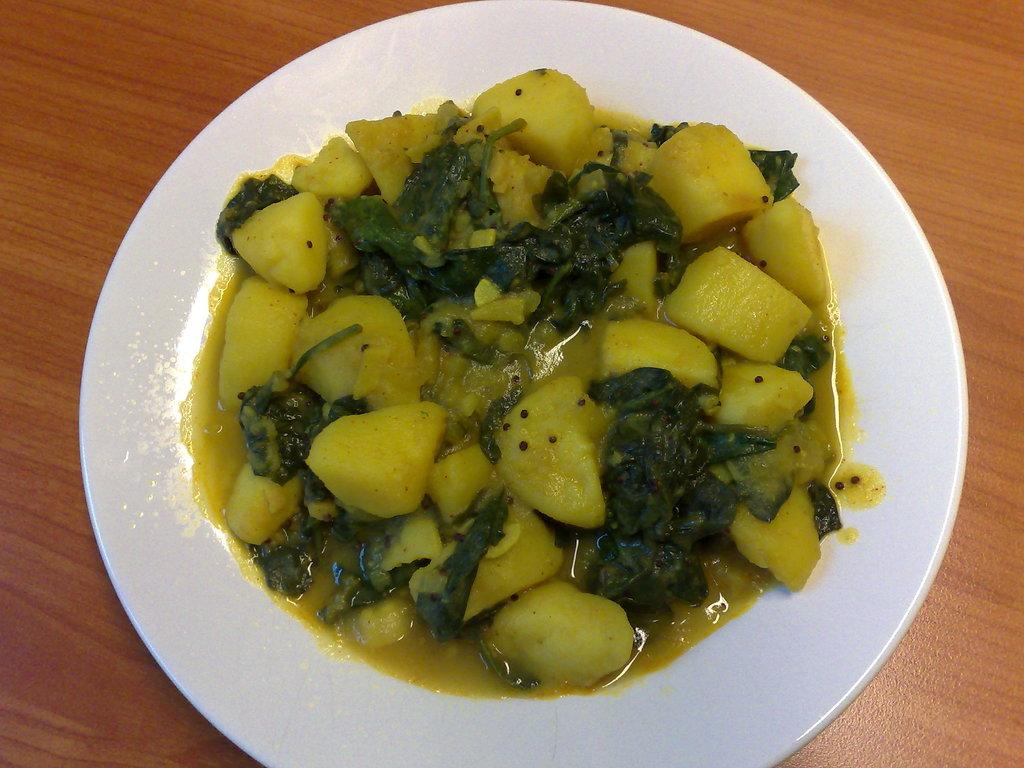What is on the plate that is visible in the image? There is food on a plate in the image. What type of surface is the plate resting on? There is a wooden surface in the image. What is the chance of the food on the plate growing an arm in the image? There is no chance of the food on the plate growing an arm in the image, as food does not have the ability to grow body parts. 